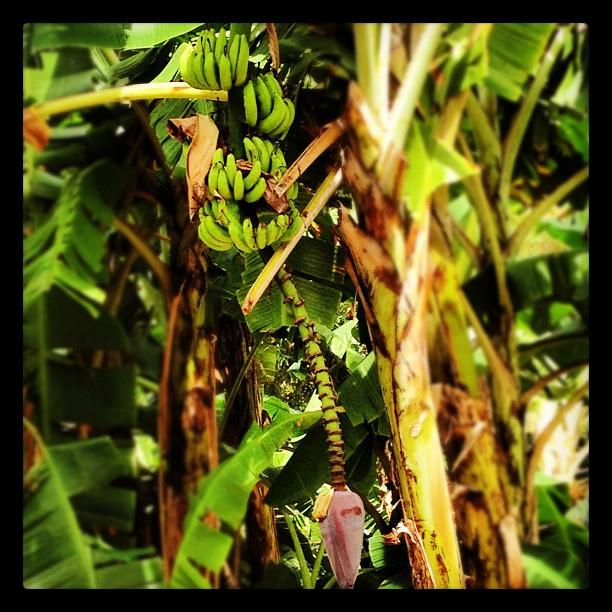Why are the bananas green? Please explain your reasoning. unripe. When bananas are are ripe they are yellow. when bananas aren't ripe they are green. 